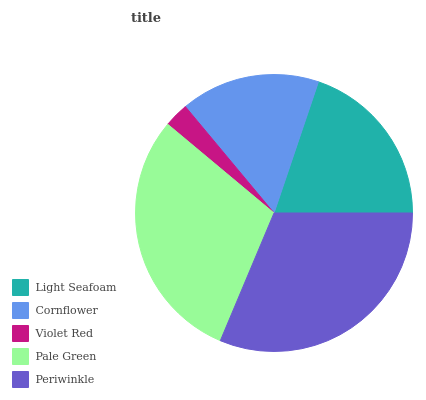Is Violet Red the minimum?
Answer yes or no. Yes. Is Periwinkle the maximum?
Answer yes or no. Yes. Is Cornflower the minimum?
Answer yes or no. No. Is Cornflower the maximum?
Answer yes or no. No. Is Light Seafoam greater than Cornflower?
Answer yes or no. Yes. Is Cornflower less than Light Seafoam?
Answer yes or no. Yes. Is Cornflower greater than Light Seafoam?
Answer yes or no. No. Is Light Seafoam less than Cornflower?
Answer yes or no. No. Is Light Seafoam the high median?
Answer yes or no. Yes. Is Light Seafoam the low median?
Answer yes or no. Yes. Is Pale Green the high median?
Answer yes or no. No. Is Cornflower the low median?
Answer yes or no. No. 